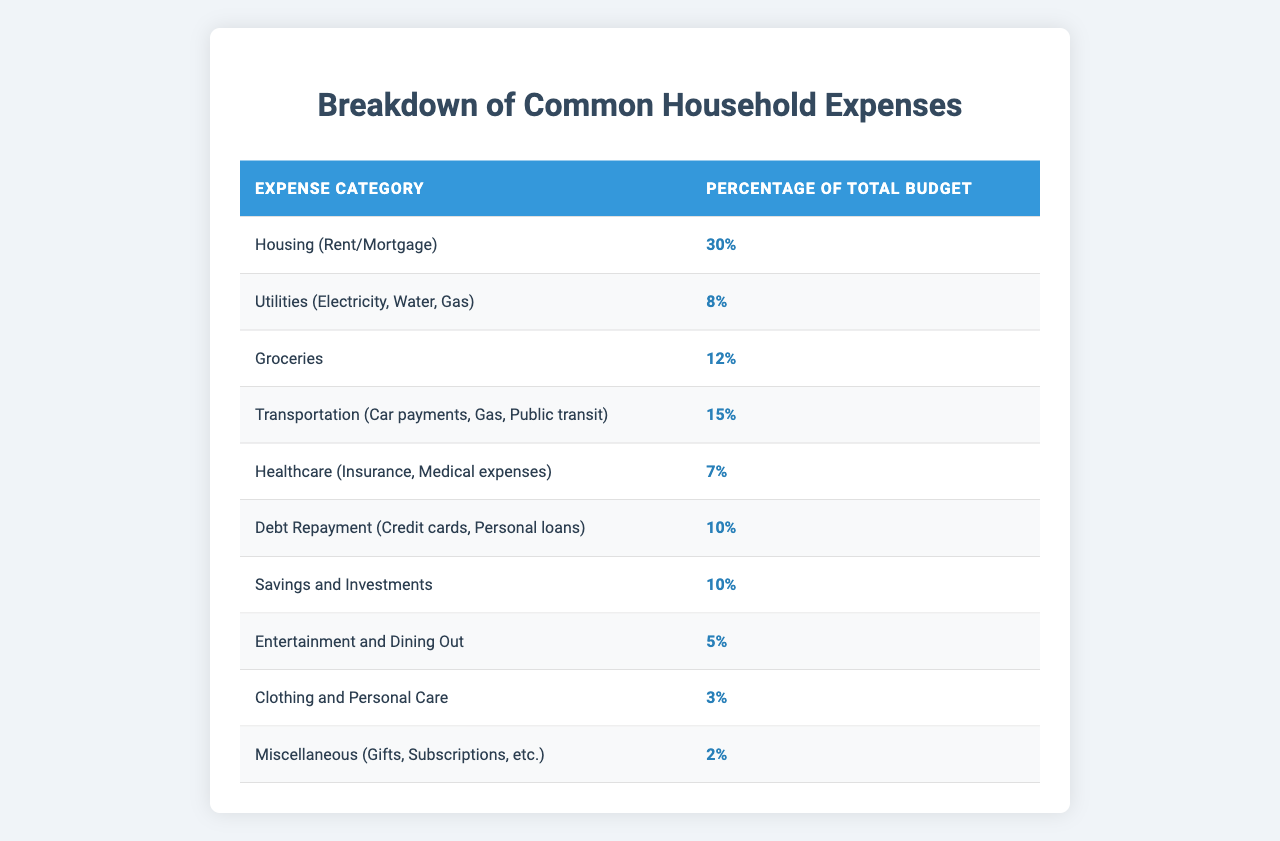What percentage of the total budget is allocated to Housing? The table clearly shows that Housing (Rent/Mortgage) accounts for 30% of the total budget.
Answer: 30% How much of the total budget is spent on Transportation? According to the table, Transportation (Car payments, Gas, Public transit) takes up 15% of the total budget.
Answer: 15% Is the amount spent on Utilities greater than that on Healthcare? The table indicates that Utilities (8%) is greater than Healthcare (7%). Therefore, the statement is true.
Answer: Yes What is the combined percentage of expenses for Debt Repayment and Healthcare? To find the combined percentage, add Debt Repayment (10%) and Healthcare (7%): 10% + 7% = 17%.
Answer: 17% If you were to reduce the Entertainment and Dining Out budget by half, what would the new percentage be? The current percentage for Entertainment and Dining Out is 5%. Half of this would be 5% / 2 = 2.5%.
Answer: 2.5% What is the percentage difference between the budget for Groceries and Clothing and Personal Care? The budget for Groceries is 12% and Clothing and Personal Care is 3%. The difference is 12% - 3% = 9%.
Answer: 9% Which expense category has the lowest percentage of the total budget? The table shows that Miscellaneous (Gifts, Subscriptions, etc.) has the lowest percentage at 2%.
Answer: 2% If you were to combine the percentages for Savings and Investments with Debt Repayment, what would be the total percentage? The table indicates Savings and Investments is 10% and Debt Repayment is 10%. The total is 10% + 10% = 20%.
Answer: 20% What percentage of the total budget is allocated to Groceries compared to Utilities? Groceries accounts for 12% and Utilities for 8%. The comparison shows Groceries has a higher percentage: 12% > 8%.
Answer: Groceries is higher If you add up all the expense categories listed, do they equal 100%? The sum of the listed percentages is calculated as follows: 30% + 8% + 12% + 15% + 7% + 10% + 10% + 5% + 3% + 2% = 100%. This confirms the total budget.
Answer: Yes 